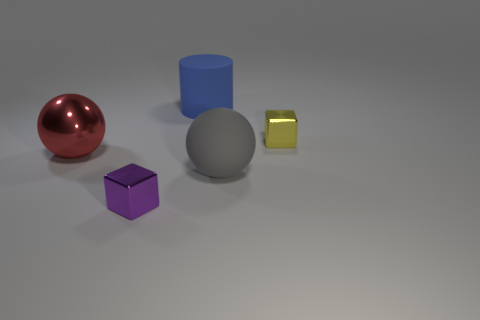What number of other objects are there of the same size as the yellow thing?
Ensure brevity in your answer.  1. Are the big blue cylinder and the small cube left of the large gray object made of the same material?
Keep it short and to the point. No. How many things are either metallic objects that are in front of the large blue thing or large objects that are right of the cylinder?
Your answer should be very brief. 4. The large rubber ball is what color?
Keep it short and to the point. Gray. Are there fewer red shiny objects right of the big blue cylinder than yellow shiny objects?
Ensure brevity in your answer.  Yes. Is there anything else that is the same shape as the blue matte object?
Provide a succinct answer. No. Are any small yellow metallic things visible?
Keep it short and to the point. Yes. Are there fewer tiny yellow cubes than big red metallic cylinders?
Give a very brief answer. No. What number of big gray objects have the same material as the tiny yellow block?
Provide a succinct answer. 0. The ball that is made of the same material as the small yellow thing is what color?
Offer a terse response. Red. 